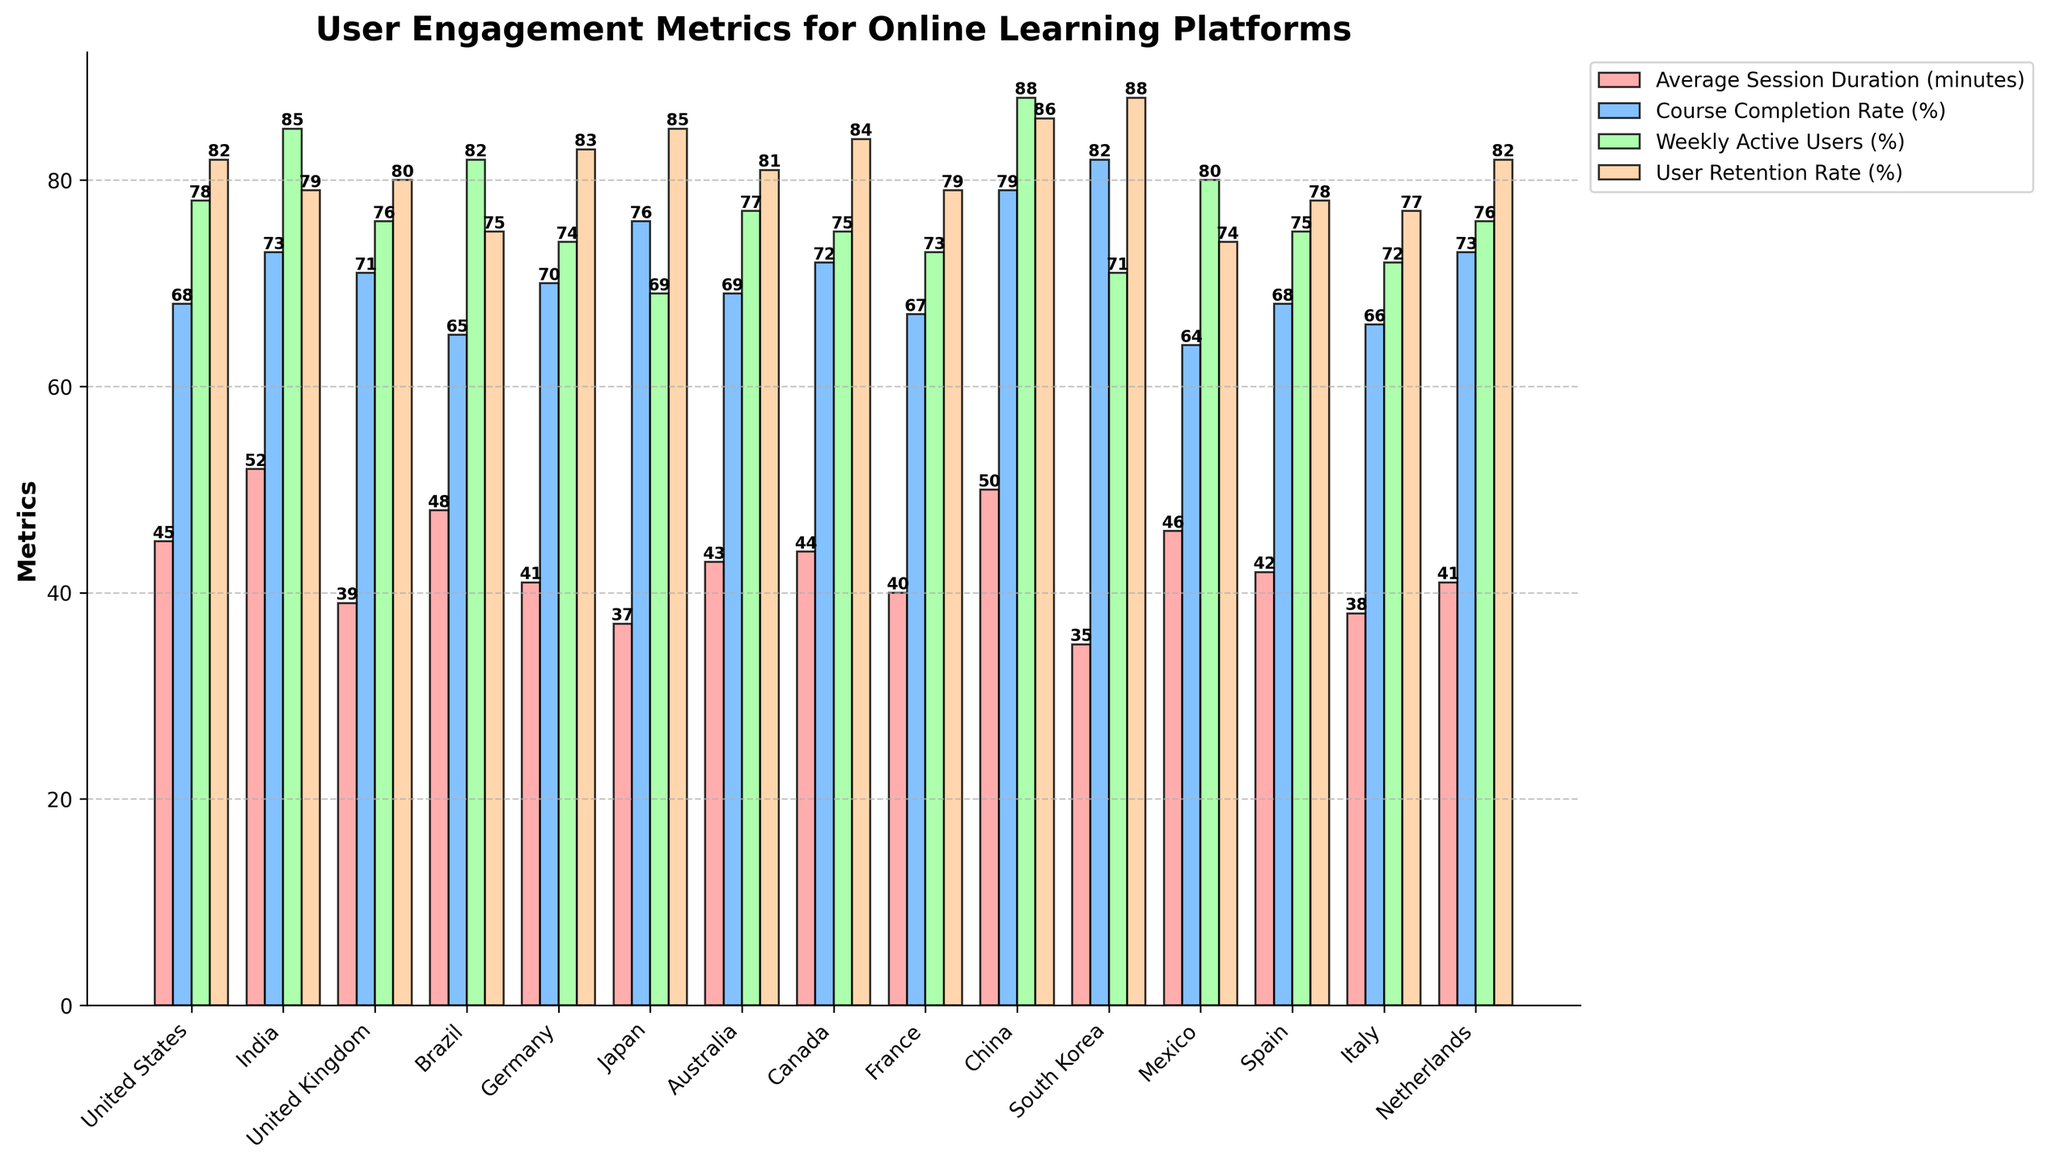Which country has the highest user retention rate? Among all the countries, South Korea has the highest bar in the User Retention Rate category, surpassing 85%.
Answer: South Korea Which country has the lowest average session duration? South Korea has the shortest bar for Average Session Duration, which is below 40 minutes.
Answer: South Korea How much higher is Japan's course completion rate compared to the average session duration? Japan's course completion rate is 76%, and its average session duration is 37 minutes. The difference is 76 - 37 = 39%.
Answer: 39% What is the total weekly active users' percentage for India and China combined? India's weekly active users percentage is 85%, and China's is 88%. Adding them together gives 85 + 88 = 173%.
Answer: 173% Which country shows the most balanced performance across all metrics? Canada has consistent bar heights across all metrics, with values of 44, 72, 75, and 84, making it well-balanced.
Answer: Canada How does Brazil's user retention rate compare to Australia's? Brazil's user retention rate is indicated by a bar of height 75%, while Australia's corresponding bar is at 81%. Since 75 < 81, Brazil's rate is lower.
Answer: Lower Which metric shows the widest variation across countries? User Retention Rate (%) has a wide range from 74% to 88%. Visually, its bars show more variation in height compared to the other metrics.
Answer: User Retention Rate Between the United States and the United Kingdom, which country has higher average session duration, and by how much? The United States has an average session duration of 45 minutes, while the United Kingdom has 39 minutes. The difference is 45 - 39 = 6 minutes.
Answer: United States, 6 minutes What is the total user retention rate percentage for Germany, Canada, and Japan? Germany's user retention rate is 83%, Canada's is 84%, and Japan's is 85%. Adding them together gives 83 + 84 + 85 = 252%.
Answer: 252% Which country has the highest percentage of weekly active users without having the highest average session duration? China has the highest percentage of weekly active users (88%) but does not have the highest average session duration (50 minutes).
Answer: China 